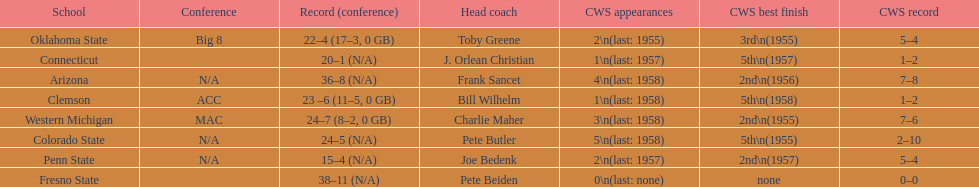Does clemson or western michigan have more cws appearances? Western Michigan. 